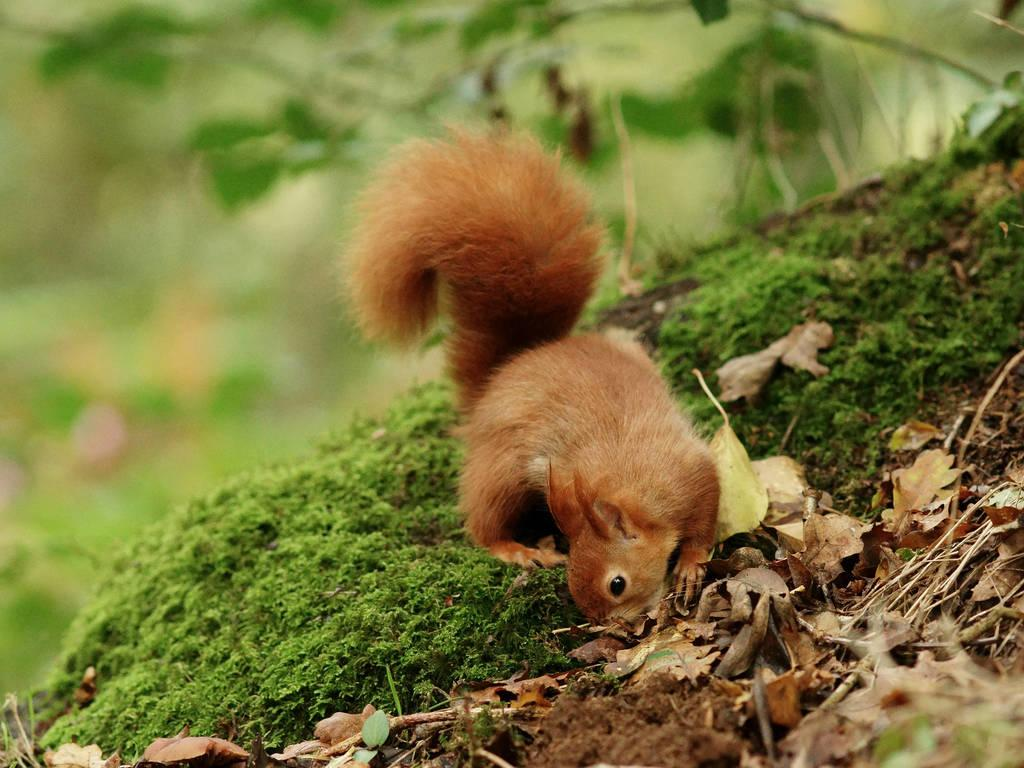What type of vegetation is visible in the image? There is grass in the image. What type of animal can be seen in the image? There is a squirrel in the image. What other type of plant is present in the image? There is a plant in the image. How would you describe the background of the image? The background of the image is blurred. What type of soup is the squirrel eating in the image? There is no soup present in the image, and the squirrel is not shown eating anything. 